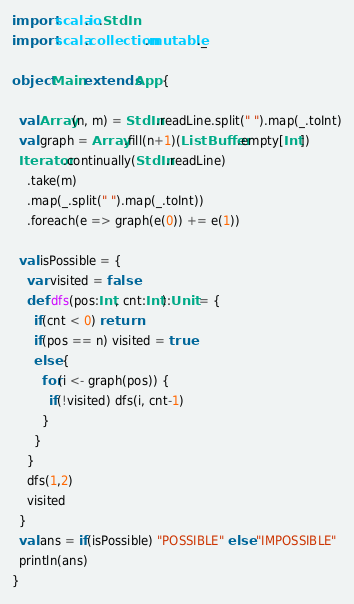<code> <loc_0><loc_0><loc_500><loc_500><_Scala_>import scala.io.StdIn
import scala.collection.mutable._

object Main extends App {

  val Array(n, m) = StdIn.readLine.split(" ").map(_.toInt)
  val graph = Array.fill(n+1)(ListBuffer.empty[Int])
  Iterator.continually(StdIn.readLine)
    .take(m)
    .map(_.split(" ").map(_.toInt))
    .foreach(e => graph(e(0)) += e(1))

  val isPossible = {
    var visited = false
    def dfs(pos:Int, cnt:Int):Unit = {
      if(cnt < 0) return
      if(pos == n) visited = true
      else {
        for(i <- graph(pos)) {
          if(!visited) dfs(i, cnt-1)
        }
      }
    }
    dfs(1,2)
    visited
  }
  val ans = if(isPossible) "POSSIBLE" else "IMPOSSIBLE"
  println(ans)
}</code> 